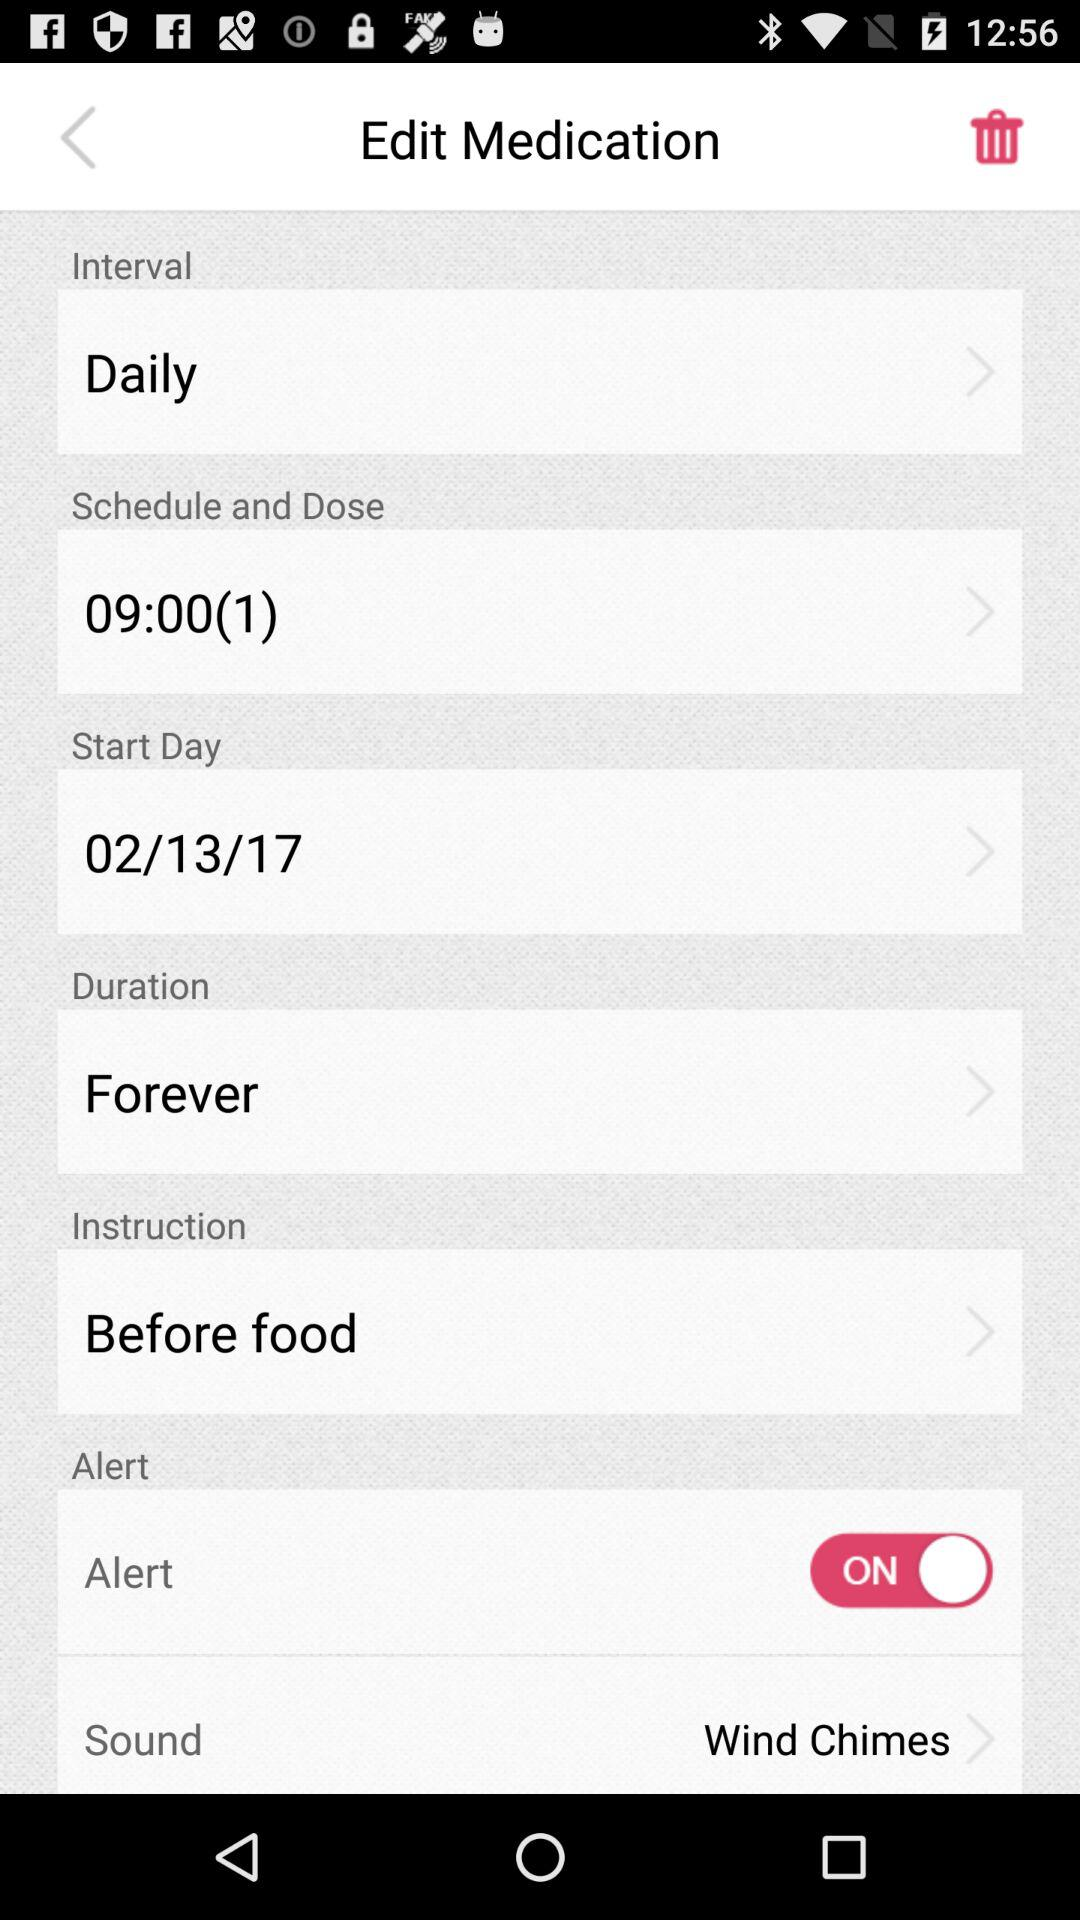What's the date of "Start Day"? The date of "Start Day" is February 13, 2017. 